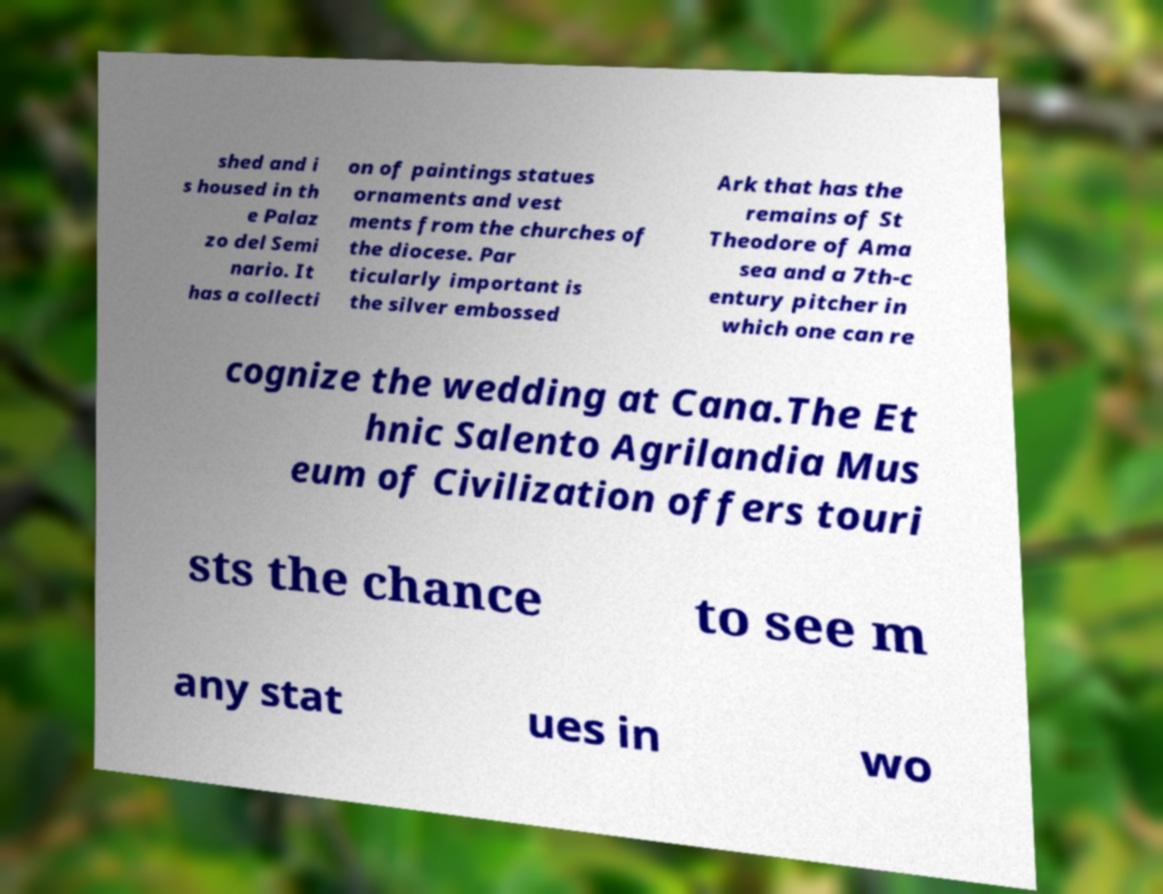Please identify and transcribe the text found in this image. shed and i s housed in th e Palaz zo del Semi nario. It has a collecti on of paintings statues ornaments and vest ments from the churches of the diocese. Par ticularly important is the silver embossed Ark that has the remains of St Theodore of Ama sea and a 7th-c entury pitcher in which one can re cognize the wedding at Cana.The Et hnic Salento Agrilandia Mus eum of Civilization offers touri sts the chance to see m any stat ues in wo 